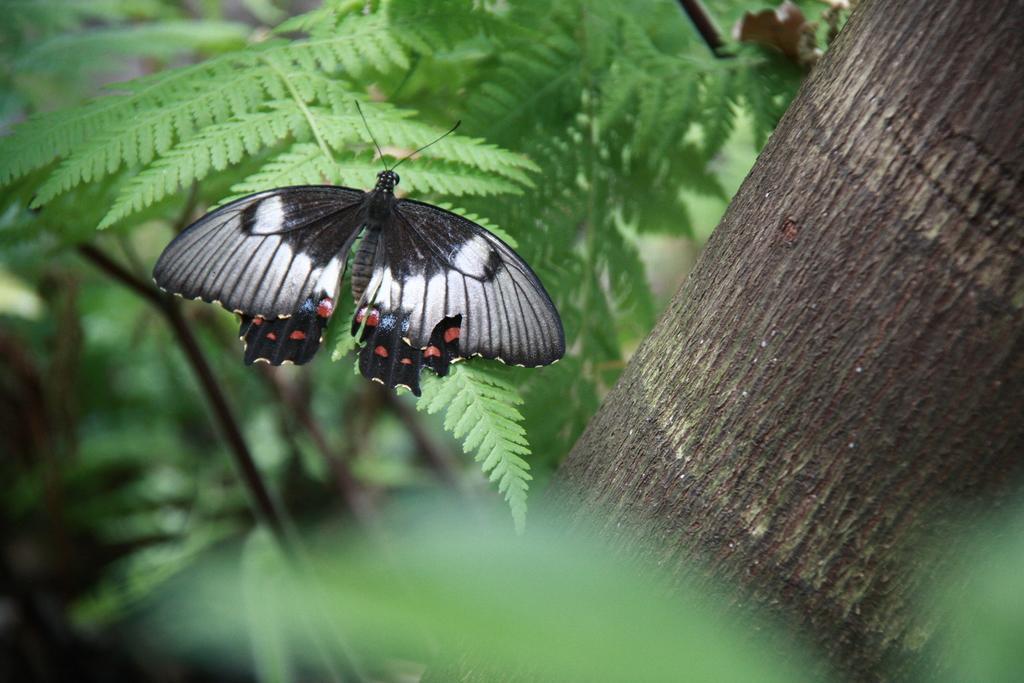How would you summarize this image in a sentence or two? In the picture we can see a butterfly. Here we can see leaves and branches. 